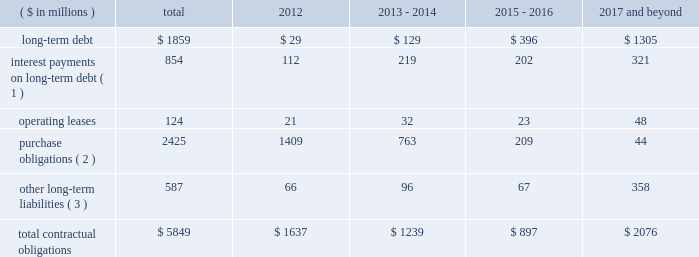Contractual obligations in 2011 , we issued $ 1200 million of senior notes and entered into the credit facility with third-party lenders in the amount of $ 1225 million .
As of december 31 , 2011 , total outstanding long-term debt was $ 1859 million , consisting of these senior notes and the credit facility , in addition to $ 105 million of third party debt that remained outstanding subsequent to the spin-off .
In connection with the spin-off , we entered into a transition services agreement with northrop grumman , under which northrop grumman or certain of its subsidiaries provides us with certain services to help ensure an orderly transition following the distribution .
Under the transition services agreement , northrop grumman provides , for up to 12 months following the spin-off , certain enterprise shared services ( including information technology , resource planning , financial , procurement and human resource services ) , benefits support services and other specified services .
The original term of the transition services agreement ends on march 31 , 2012 , although we have the right to and have cancelled certain services as we transition to new third-party providers .
The services provided by northrop grumman are charged to us at cost , and a limited number of these services may be extended for a period of approximately six months to allow full information systems transition .
See note 20 : related party transactions and former parent company equity in item 8 .
In connection with the spin-off , we entered into a tax matters agreement with northrop grumman ( the 201ctax matters agreement 201d ) that governs the respective rights , responsibilities and obligations of northrop grumman and us after the spin-off with respect to tax liabilities and benefits , tax attributes , tax contests and other tax sharing regarding u.s .
Federal , state , local and foreign income taxes , other taxes and related tax returns .
We have several liabilities with northrop grumman to the irs for the consolidated u.s .
Federal income taxes of the northrop grumman consolidated group relating to the taxable periods in which we were part of that group .
However , the tax matters agreement specifies the portion of this tax liability for which we will bear responsibility , and northrop grumman has agreed to indemnify us against any amounts for which we are not responsible .
The tax matters agreement also provides special rules for allocating tax liabilities in the event that the spin-off , together with certain related transactions , is not tax-free .
See note 20 : related party transactions and former parent company equity in item 8 .
We do not expect either the transition services agreement or the tax matters agreement to have a significant impact on our financial condition and results of operations .
The table presents our contractual obligations as of december 31 , 2011 , and the related estimated timing of future cash payments : ( $ in millions ) total 2012 2013 - 2014 2015 - 2016 2017 and beyond .
( 1 ) interest payments include interest on $ 554 million of variable interest rate debt calculated based on interest rates at december 31 , 2011 .
( 2 ) a 201cpurchase obligation 201d is defined as an agreement to purchase goods or services that is enforceable and legally binding on us and that specifies all significant terms , including : fixed or minimum quantities to be purchased ; fixed , minimum , or variable price provisions ; and the approximate timing of the transaction .
These amounts are primarily comprised of open purchase order commitments to vendors and subcontractors pertaining to funded contracts .
( 3 ) other long-term liabilities primarily consist of total accrued workers 2019 compensation reserves , deferred compensation , and other miscellaneous liabilities , of which $ 201 million is the current portion of workers 2019 compensation liabilities .
It excludes obligations for uncertain tax positions of $ 9 million , as the timing of the payments , if any , cannot be reasonably estimated .
The above table excludes retirement related contributions .
In 2012 , we expect to make minimum and discretionary contributions to our qualified pension plans of approximately $ 153 million and $ 65 million , respectively , exclusive of any u.s .
Government recoveries .
We will continue to periodically evaluate whether to make additional discretionary contributions .
In 2012 , we expect to make $ 35 million in contributions for our other postretirement plans , exclusive of any .
What portion of the long-term debt is included in the section of current liabilities on the balance sheet as of december 31 , 2012? 
Computations: (129 / (1859 - 29))
Answer: 0.07049. 